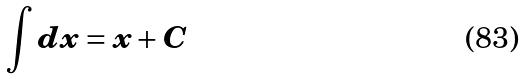<formula> <loc_0><loc_0><loc_500><loc_500>\int d x = x + C</formula> 